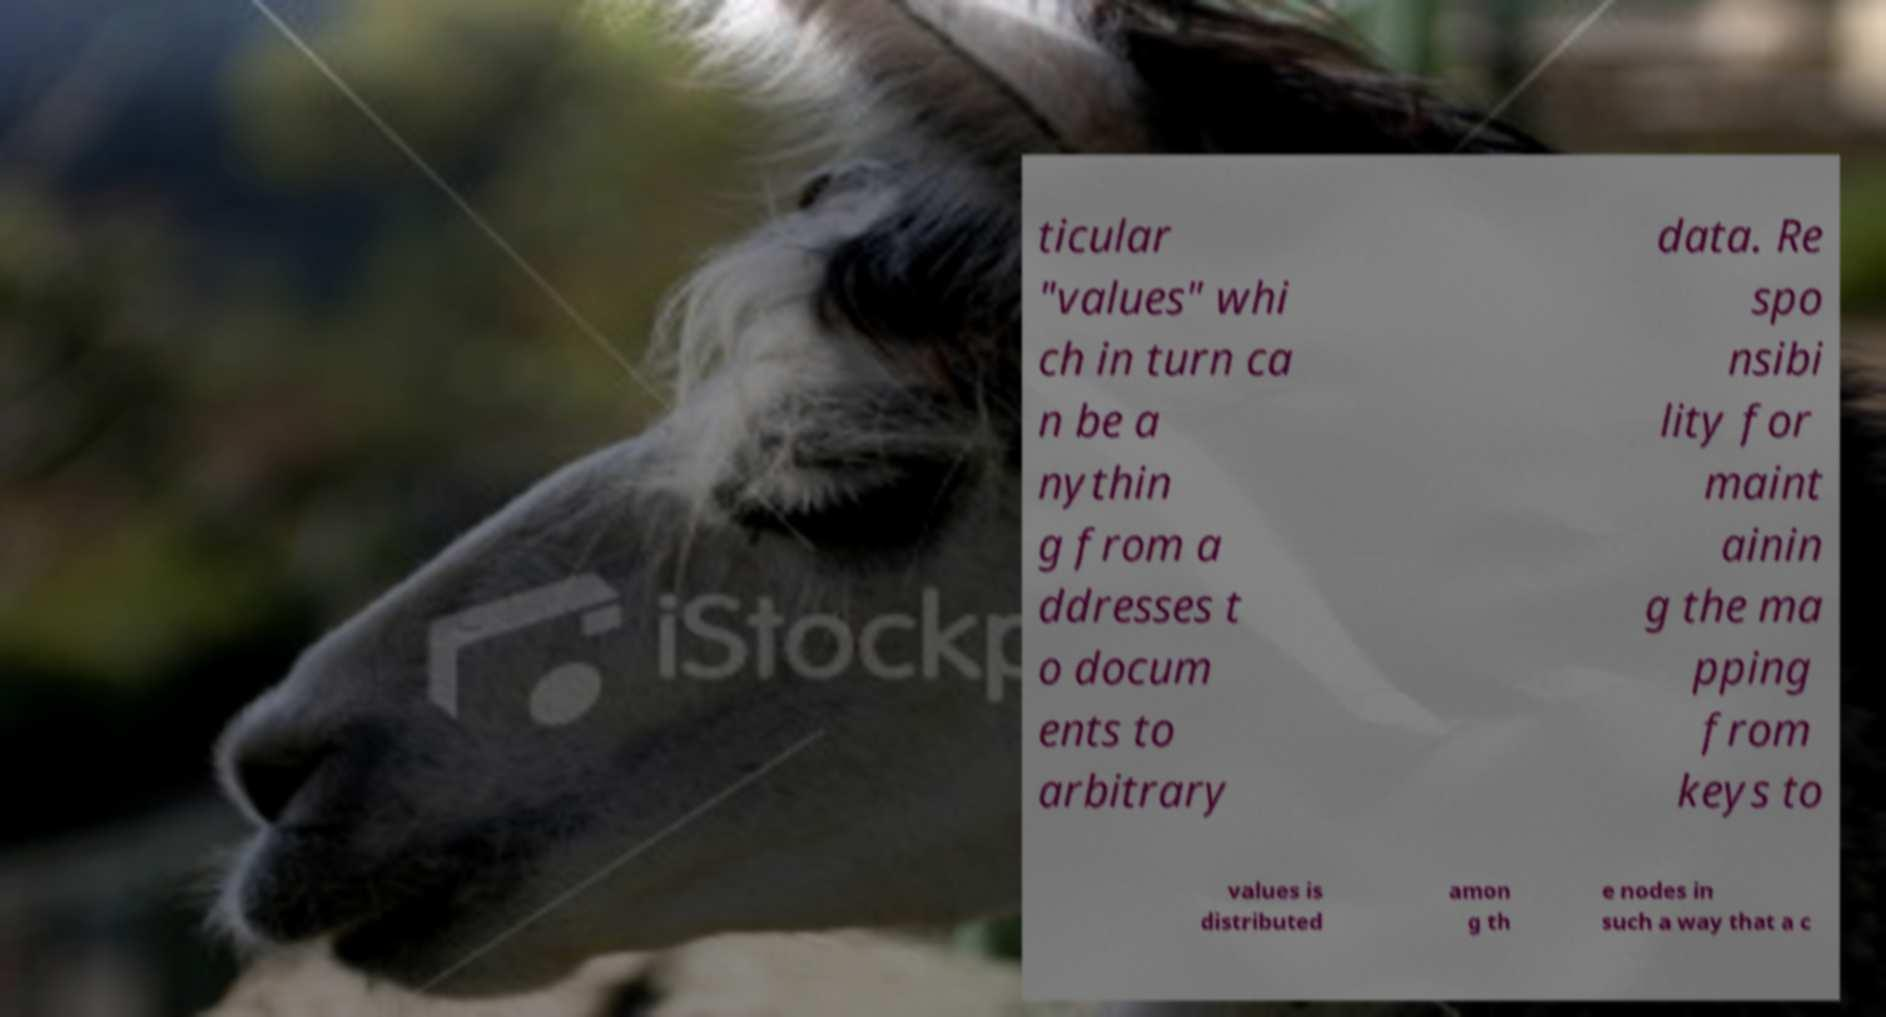I need the written content from this picture converted into text. Can you do that? ticular "values" whi ch in turn ca n be a nythin g from a ddresses t o docum ents to arbitrary data. Re spo nsibi lity for maint ainin g the ma pping from keys to values is distributed amon g th e nodes in such a way that a c 